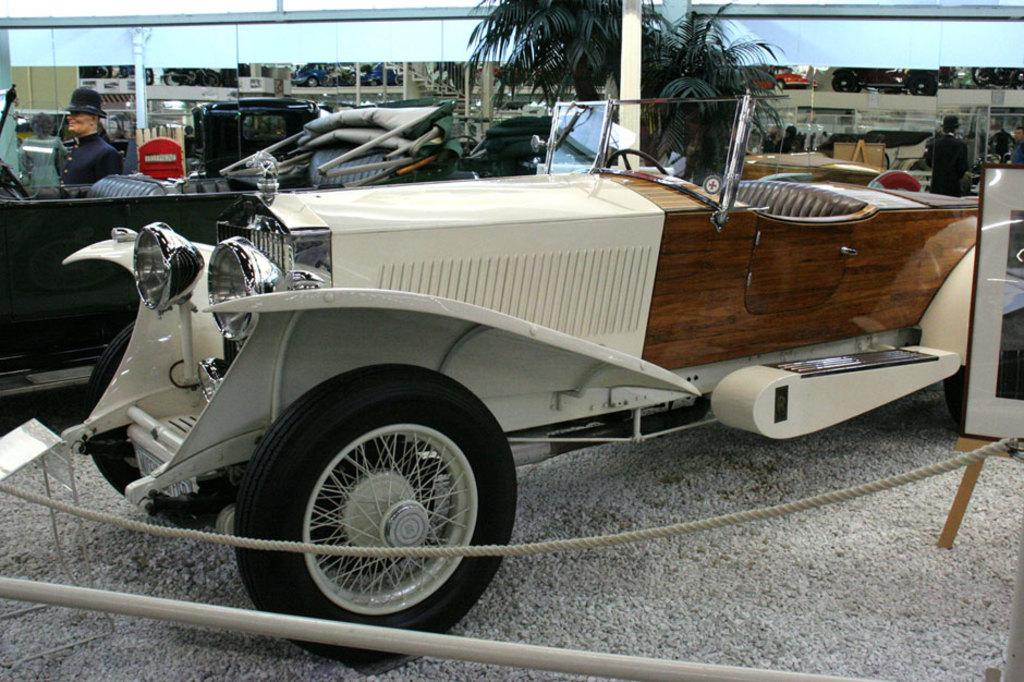What types of objects are present in the image? There are vehicles, people standing, a person sitting, a rope, a board, trees, and a pole in the image. Can you describe the people in the image? There are people standing and one person sitting in the image. What is the rope used for in the image? The purpose of the rope in the image is not clear, but it is present. What can be seen in the background of the image? Trees and a pole are visible in the background of the image. What type of net is being used to catch the ice in the image? There is: There is no net or ice present in the image. 